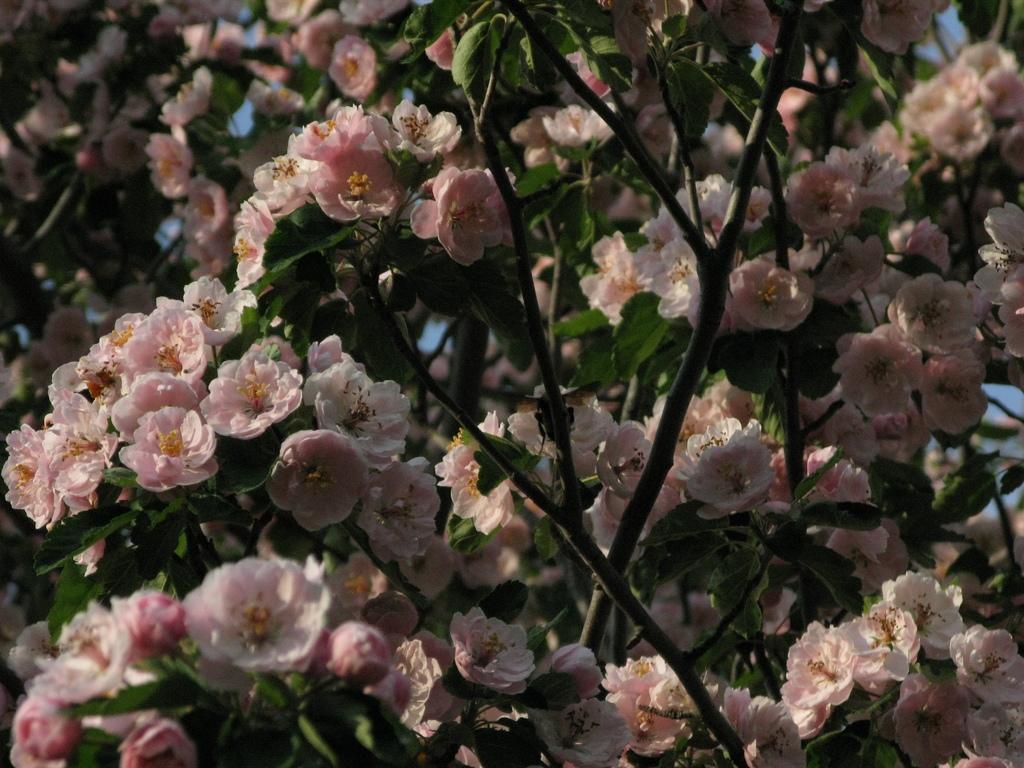Describe this image in one or two sentences. In this image I see number of planets and I see flowers on it which are of pink in color. 